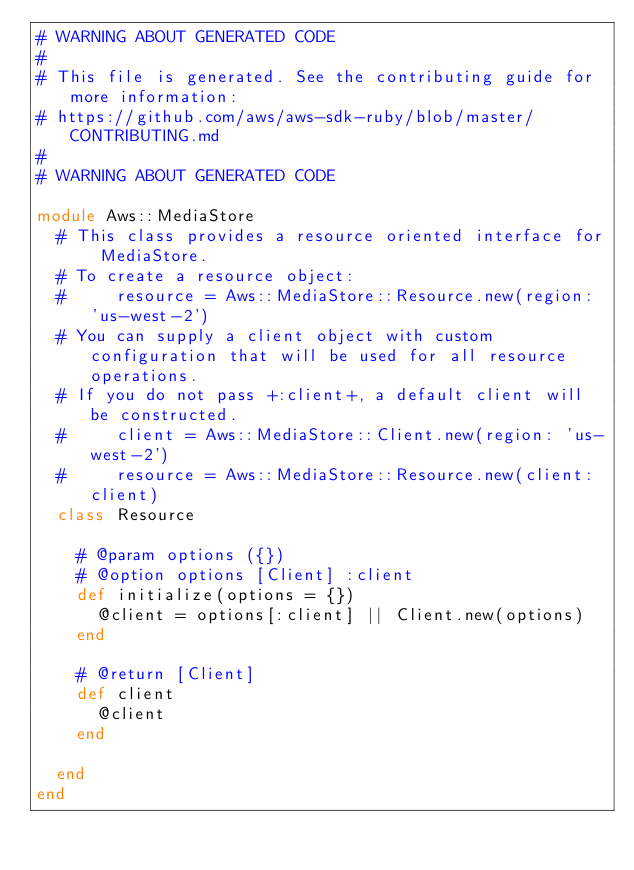<code> <loc_0><loc_0><loc_500><loc_500><_Ruby_># WARNING ABOUT GENERATED CODE
#
# This file is generated. See the contributing guide for more information:
# https://github.com/aws/aws-sdk-ruby/blob/master/CONTRIBUTING.md
#
# WARNING ABOUT GENERATED CODE

module Aws::MediaStore
  # This class provides a resource oriented interface for MediaStore.
  # To create a resource object:
  #     resource = Aws::MediaStore::Resource.new(region: 'us-west-2')
  # You can supply a client object with custom configuration that will be used for all resource operations.
  # If you do not pass +:client+, a default client will be constructed.
  #     client = Aws::MediaStore::Client.new(region: 'us-west-2')
  #     resource = Aws::MediaStore::Resource.new(client: client)
  class Resource

    # @param options ({})
    # @option options [Client] :client
    def initialize(options = {})
      @client = options[:client] || Client.new(options)
    end

    # @return [Client]
    def client
      @client
    end

  end
end
</code> 